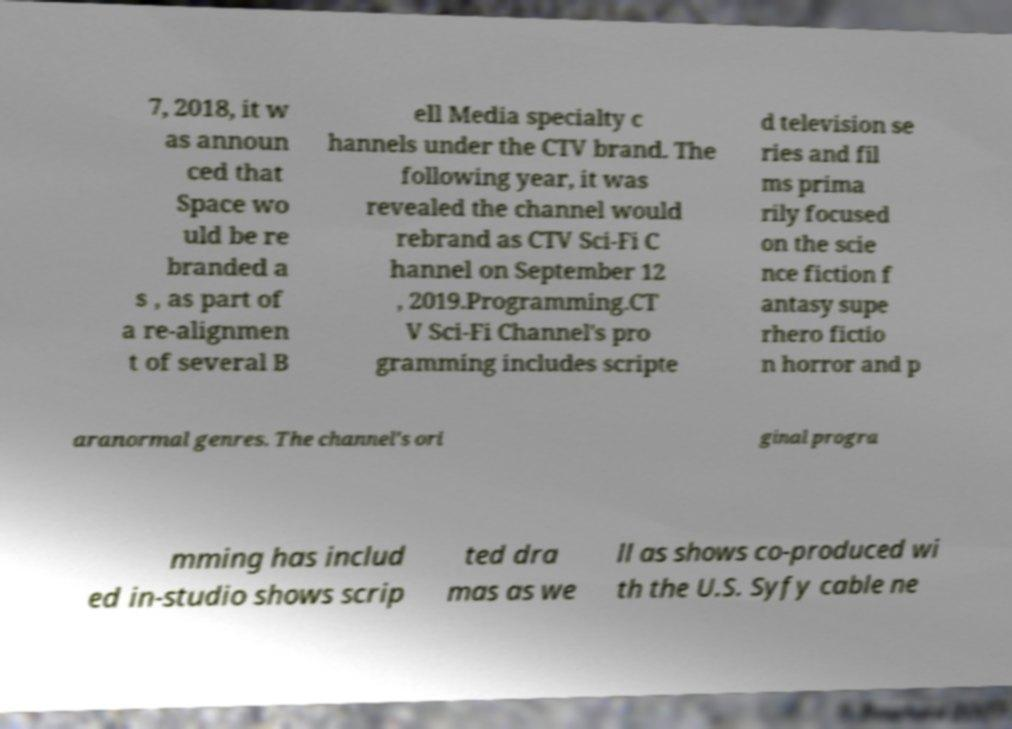Could you assist in decoding the text presented in this image and type it out clearly? 7, 2018, it w as announ ced that Space wo uld be re branded a s , as part of a re-alignmen t of several B ell Media specialty c hannels under the CTV brand. The following year, it was revealed the channel would rebrand as CTV Sci-Fi C hannel on September 12 , 2019.Programming.CT V Sci-Fi Channel's pro gramming includes scripte d television se ries and fil ms prima rily focused on the scie nce fiction f antasy supe rhero fictio n horror and p aranormal genres. The channel's ori ginal progra mming has includ ed in-studio shows scrip ted dra mas as we ll as shows co-produced wi th the U.S. Syfy cable ne 